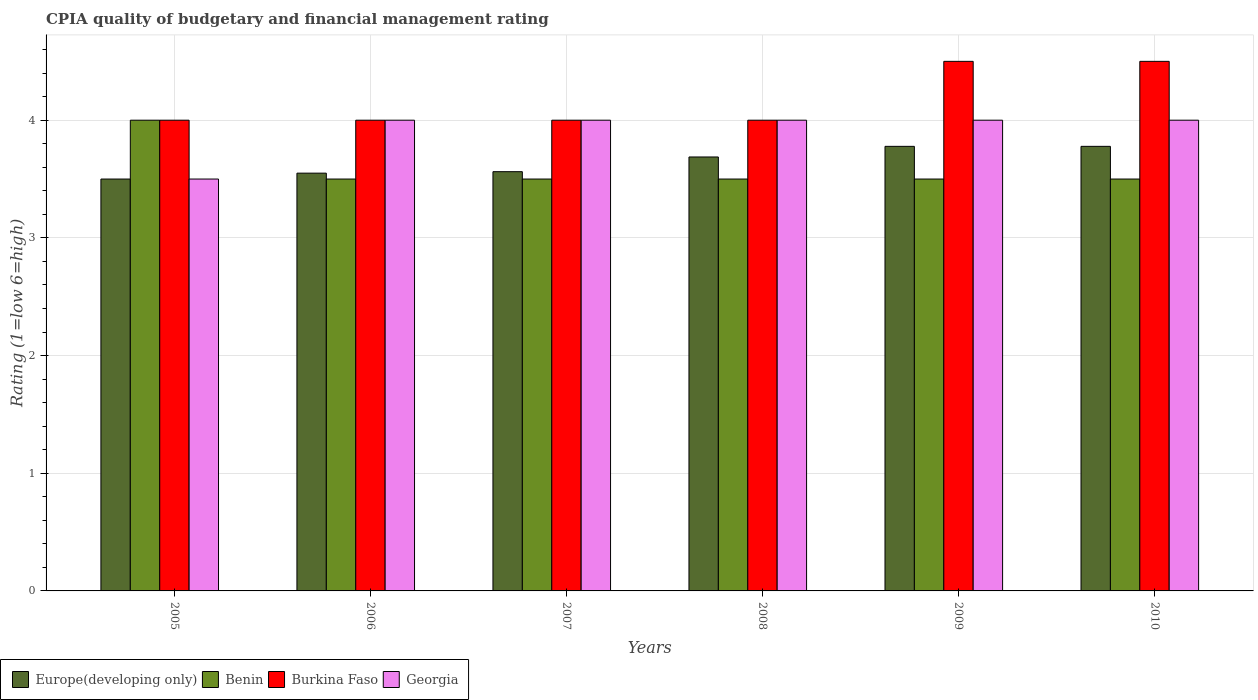How many different coloured bars are there?
Ensure brevity in your answer.  4. How many groups of bars are there?
Keep it short and to the point. 6. Are the number of bars per tick equal to the number of legend labels?
Offer a very short reply. Yes. Are the number of bars on each tick of the X-axis equal?
Offer a terse response. Yes. How many bars are there on the 3rd tick from the right?
Your answer should be very brief. 4. What is the label of the 6th group of bars from the left?
Provide a succinct answer. 2010. In how many cases, is the number of bars for a given year not equal to the number of legend labels?
Offer a very short reply. 0. What is the CPIA rating in Benin in 2005?
Keep it short and to the point. 4. Across all years, what is the maximum CPIA rating in Georgia?
Your answer should be compact. 4. Across all years, what is the minimum CPIA rating in Georgia?
Your answer should be very brief. 3.5. In which year was the CPIA rating in Georgia maximum?
Your response must be concise. 2006. In which year was the CPIA rating in Burkina Faso minimum?
Provide a short and direct response. 2005. What is the total CPIA rating in Benin in the graph?
Ensure brevity in your answer.  21.5. What is the difference between the CPIA rating in Europe(developing only) in 2005 and that in 2008?
Keep it short and to the point. -0.19. What is the difference between the CPIA rating in Benin in 2010 and the CPIA rating in Europe(developing only) in 2005?
Provide a succinct answer. 0. What is the average CPIA rating in Europe(developing only) per year?
Offer a very short reply. 3.64. In the year 2007, what is the difference between the CPIA rating in Burkina Faso and CPIA rating in Georgia?
Make the answer very short. 0. What is the ratio of the CPIA rating in Burkina Faso in 2008 to that in 2010?
Keep it short and to the point. 0.89. Is the CPIA rating in Georgia in 2007 less than that in 2009?
Your answer should be very brief. No. Is the difference between the CPIA rating in Burkina Faso in 2005 and 2009 greater than the difference between the CPIA rating in Georgia in 2005 and 2009?
Keep it short and to the point. No. In how many years, is the CPIA rating in Benin greater than the average CPIA rating in Benin taken over all years?
Offer a very short reply. 1. What does the 2nd bar from the left in 2009 represents?
Your answer should be compact. Benin. What does the 2nd bar from the right in 2008 represents?
Your answer should be compact. Burkina Faso. Is it the case that in every year, the sum of the CPIA rating in Burkina Faso and CPIA rating in Europe(developing only) is greater than the CPIA rating in Benin?
Provide a succinct answer. Yes. How many bars are there?
Provide a succinct answer. 24. Are the values on the major ticks of Y-axis written in scientific E-notation?
Provide a short and direct response. No. Does the graph contain any zero values?
Offer a very short reply. No. Does the graph contain grids?
Your answer should be very brief. Yes. What is the title of the graph?
Keep it short and to the point. CPIA quality of budgetary and financial management rating. Does "Mexico" appear as one of the legend labels in the graph?
Your response must be concise. No. What is the Rating (1=low 6=high) of Benin in 2005?
Your response must be concise. 4. What is the Rating (1=low 6=high) in Georgia in 2005?
Provide a short and direct response. 3.5. What is the Rating (1=low 6=high) in Europe(developing only) in 2006?
Your answer should be very brief. 3.55. What is the Rating (1=low 6=high) of Burkina Faso in 2006?
Provide a succinct answer. 4. What is the Rating (1=low 6=high) in Europe(developing only) in 2007?
Keep it short and to the point. 3.56. What is the Rating (1=low 6=high) of Benin in 2007?
Your answer should be very brief. 3.5. What is the Rating (1=low 6=high) in Georgia in 2007?
Ensure brevity in your answer.  4. What is the Rating (1=low 6=high) of Europe(developing only) in 2008?
Provide a short and direct response. 3.69. What is the Rating (1=low 6=high) in Benin in 2008?
Your answer should be compact. 3.5. What is the Rating (1=low 6=high) of Burkina Faso in 2008?
Offer a very short reply. 4. What is the Rating (1=low 6=high) in Georgia in 2008?
Offer a very short reply. 4. What is the Rating (1=low 6=high) in Europe(developing only) in 2009?
Ensure brevity in your answer.  3.78. What is the Rating (1=low 6=high) of Benin in 2009?
Ensure brevity in your answer.  3.5. What is the Rating (1=low 6=high) of Europe(developing only) in 2010?
Your answer should be compact. 3.78. Across all years, what is the maximum Rating (1=low 6=high) in Europe(developing only)?
Ensure brevity in your answer.  3.78. Across all years, what is the maximum Rating (1=low 6=high) in Benin?
Provide a short and direct response. 4. Across all years, what is the maximum Rating (1=low 6=high) of Burkina Faso?
Offer a terse response. 4.5. Across all years, what is the maximum Rating (1=low 6=high) in Georgia?
Offer a very short reply. 4. Across all years, what is the minimum Rating (1=low 6=high) in Burkina Faso?
Ensure brevity in your answer.  4. What is the total Rating (1=low 6=high) of Europe(developing only) in the graph?
Offer a terse response. 21.86. What is the total Rating (1=low 6=high) in Georgia in the graph?
Your response must be concise. 23.5. What is the difference between the Rating (1=low 6=high) of Europe(developing only) in 2005 and that in 2006?
Provide a succinct answer. -0.05. What is the difference between the Rating (1=low 6=high) in Benin in 2005 and that in 2006?
Offer a terse response. 0.5. What is the difference between the Rating (1=low 6=high) of Georgia in 2005 and that in 2006?
Ensure brevity in your answer.  -0.5. What is the difference between the Rating (1=low 6=high) of Europe(developing only) in 2005 and that in 2007?
Give a very brief answer. -0.06. What is the difference between the Rating (1=low 6=high) of Benin in 2005 and that in 2007?
Your answer should be very brief. 0.5. What is the difference between the Rating (1=low 6=high) of Georgia in 2005 and that in 2007?
Offer a terse response. -0.5. What is the difference between the Rating (1=low 6=high) in Europe(developing only) in 2005 and that in 2008?
Keep it short and to the point. -0.19. What is the difference between the Rating (1=low 6=high) in Benin in 2005 and that in 2008?
Keep it short and to the point. 0.5. What is the difference between the Rating (1=low 6=high) in Europe(developing only) in 2005 and that in 2009?
Keep it short and to the point. -0.28. What is the difference between the Rating (1=low 6=high) of Europe(developing only) in 2005 and that in 2010?
Your response must be concise. -0.28. What is the difference between the Rating (1=low 6=high) in Georgia in 2005 and that in 2010?
Provide a succinct answer. -0.5. What is the difference between the Rating (1=low 6=high) of Europe(developing only) in 2006 and that in 2007?
Offer a very short reply. -0.01. What is the difference between the Rating (1=low 6=high) in Burkina Faso in 2006 and that in 2007?
Your response must be concise. 0. What is the difference between the Rating (1=low 6=high) of Georgia in 2006 and that in 2007?
Offer a very short reply. 0. What is the difference between the Rating (1=low 6=high) of Europe(developing only) in 2006 and that in 2008?
Your answer should be very brief. -0.14. What is the difference between the Rating (1=low 6=high) of Georgia in 2006 and that in 2008?
Your answer should be compact. 0. What is the difference between the Rating (1=low 6=high) in Europe(developing only) in 2006 and that in 2009?
Make the answer very short. -0.23. What is the difference between the Rating (1=low 6=high) in Georgia in 2006 and that in 2009?
Give a very brief answer. 0. What is the difference between the Rating (1=low 6=high) in Europe(developing only) in 2006 and that in 2010?
Provide a succinct answer. -0.23. What is the difference between the Rating (1=low 6=high) in Europe(developing only) in 2007 and that in 2008?
Make the answer very short. -0.12. What is the difference between the Rating (1=low 6=high) in Burkina Faso in 2007 and that in 2008?
Give a very brief answer. 0. What is the difference between the Rating (1=low 6=high) in Europe(developing only) in 2007 and that in 2009?
Provide a short and direct response. -0.22. What is the difference between the Rating (1=low 6=high) in Benin in 2007 and that in 2009?
Give a very brief answer. 0. What is the difference between the Rating (1=low 6=high) of Burkina Faso in 2007 and that in 2009?
Ensure brevity in your answer.  -0.5. What is the difference between the Rating (1=low 6=high) in Georgia in 2007 and that in 2009?
Keep it short and to the point. 0. What is the difference between the Rating (1=low 6=high) of Europe(developing only) in 2007 and that in 2010?
Keep it short and to the point. -0.22. What is the difference between the Rating (1=low 6=high) in Burkina Faso in 2007 and that in 2010?
Your answer should be compact. -0.5. What is the difference between the Rating (1=low 6=high) of Georgia in 2007 and that in 2010?
Make the answer very short. 0. What is the difference between the Rating (1=low 6=high) of Europe(developing only) in 2008 and that in 2009?
Provide a short and direct response. -0.09. What is the difference between the Rating (1=low 6=high) in Burkina Faso in 2008 and that in 2009?
Your response must be concise. -0.5. What is the difference between the Rating (1=low 6=high) in Europe(developing only) in 2008 and that in 2010?
Give a very brief answer. -0.09. What is the difference between the Rating (1=low 6=high) of Burkina Faso in 2008 and that in 2010?
Offer a very short reply. -0.5. What is the difference between the Rating (1=low 6=high) of Georgia in 2008 and that in 2010?
Make the answer very short. 0. What is the difference between the Rating (1=low 6=high) of Benin in 2009 and that in 2010?
Give a very brief answer. 0. What is the difference between the Rating (1=low 6=high) in Burkina Faso in 2009 and that in 2010?
Make the answer very short. 0. What is the difference between the Rating (1=low 6=high) of Georgia in 2009 and that in 2010?
Your answer should be very brief. 0. What is the difference between the Rating (1=low 6=high) of Europe(developing only) in 2005 and the Rating (1=low 6=high) of Benin in 2006?
Your answer should be very brief. 0. What is the difference between the Rating (1=low 6=high) of Benin in 2005 and the Rating (1=low 6=high) of Burkina Faso in 2006?
Provide a succinct answer. 0. What is the difference between the Rating (1=low 6=high) of Burkina Faso in 2005 and the Rating (1=low 6=high) of Georgia in 2006?
Provide a succinct answer. 0. What is the difference between the Rating (1=low 6=high) in Europe(developing only) in 2005 and the Rating (1=low 6=high) in Benin in 2007?
Ensure brevity in your answer.  0. What is the difference between the Rating (1=low 6=high) of Europe(developing only) in 2005 and the Rating (1=low 6=high) of Burkina Faso in 2007?
Make the answer very short. -0.5. What is the difference between the Rating (1=low 6=high) of Europe(developing only) in 2005 and the Rating (1=low 6=high) of Georgia in 2007?
Give a very brief answer. -0.5. What is the difference between the Rating (1=low 6=high) of Benin in 2005 and the Rating (1=low 6=high) of Georgia in 2007?
Your answer should be very brief. 0. What is the difference between the Rating (1=low 6=high) of Burkina Faso in 2005 and the Rating (1=low 6=high) of Georgia in 2007?
Your response must be concise. 0. What is the difference between the Rating (1=low 6=high) in Europe(developing only) in 2005 and the Rating (1=low 6=high) in Georgia in 2008?
Your response must be concise. -0.5. What is the difference between the Rating (1=low 6=high) of Europe(developing only) in 2005 and the Rating (1=low 6=high) of Benin in 2009?
Ensure brevity in your answer.  0. What is the difference between the Rating (1=low 6=high) of Europe(developing only) in 2005 and the Rating (1=low 6=high) of Burkina Faso in 2009?
Provide a succinct answer. -1. What is the difference between the Rating (1=low 6=high) in Europe(developing only) in 2005 and the Rating (1=low 6=high) in Georgia in 2009?
Ensure brevity in your answer.  -0.5. What is the difference between the Rating (1=low 6=high) of Benin in 2005 and the Rating (1=low 6=high) of Georgia in 2009?
Offer a very short reply. 0. What is the difference between the Rating (1=low 6=high) in Burkina Faso in 2005 and the Rating (1=low 6=high) in Georgia in 2009?
Provide a short and direct response. 0. What is the difference between the Rating (1=low 6=high) of Europe(developing only) in 2005 and the Rating (1=low 6=high) of Burkina Faso in 2010?
Make the answer very short. -1. What is the difference between the Rating (1=low 6=high) in Europe(developing only) in 2005 and the Rating (1=low 6=high) in Georgia in 2010?
Give a very brief answer. -0.5. What is the difference between the Rating (1=low 6=high) in Benin in 2005 and the Rating (1=low 6=high) in Georgia in 2010?
Your answer should be compact. 0. What is the difference between the Rating (1=low 6=high) of Burkina Faso in 2005 and the Rating (1=low 6=high) of Georgia in 2010?
Provide a short and direct response. 0. What is the difference between the Rating (1=low 6=high) in Europe(developing only) in 2006 and the Rating (1=low 6=high) in Benin in 2007?
Provide a succinct answer. 0.05. What is the difference between the Rating (1=low 6=high) in Europe(developing only) in 2006 and the Rating (1=low 6=high) in Burkina Faso in 2007?
Offer a terse response. -0.45. What is the difference between the Rating (1=low 6=high) in Europe(developing only) in 2006 and the Rating (1=low 6=high) in Georgia in 2007?
Your answer should be very brief. -0.45. What is the difference between the Rating (1=low 6=high) in Benin in 2006 and the Rating (1=low 6=high) in Burkina Faso in 2007?
Offer a very short reply. -0.5. What is the difference between the Rating (1=low 6=high) of Benin in 2006 and the Rating (1=low 6=high) of Georgia in 2007?
Your answer should be compact. -0.5. What is the difference between the Rating (1=low 6=high) of Europe(developing only) in 2006 and the Rating (1=low 6=high) of Benin in 2008?
Your answer should be compact. 0.05. What is the difference between the Rating (1=low 6=high) of Europe(developing only) in 2006 and the Rating (1=low 6=high) of Burkina Faso in 2008?
Your answer should be compact. -0.45. What is the difference between the Rating (1=low 6=high) in Europe(developing only) in 2006 and the Rating (1=low 6=high) in Georgia in 2008?
Offer a very short reply. -0.45. What is the difference between the Rating (1=low 6=high) of Europe(developing only) in 2006 and the Rating (1=low 6=high) of Burkina Faso in 2009?
Offer a very short reply. -0.95. What is the difference between the Rating (1=low 6=high) of Europe(developing only) in 2006 and the Rating (1=low 6=high) of Georgia in 2009?
Offer a very short reply. -0.45. What is the difference between the Rating (1=low 6=high) of Benin in 2006 and the Rating (1=low 6=high) of Burkina Faso in 2009?
Keep it short and to the point. -1. What is the difference between the Rating (1=low 6=high) of Benin in 2006 and the Rating (1=low 6=high) of Georgia in 2009?
Ensure brevity in your answer.  -0.5. What is the difference between the Rating (1=low 6=high) of Europe(developing only) in 2006 and the Rating (1=low 6=high) of Benin in 2010?
Your answer should be compact. 0.05. What is the difference between the Rating (1=low 6=high) in Europe(developing only) in 2006 and the Rating (1=low 6=high) in Burkina Faso in 2010?
Provide a short and direct response. -0.95. What is the difference between the Rating (1=low 6=high) of Europe(developing only) in 2006 and the Rating (1=low 6=high) of Georgia in 2010?
Keep it short and to the point. -0.45. What is the difference between the Rating (1=low 6=high) of Benin in 2006 and the Rating (1=low 6=high) of Burkina Faso in 2010?
Offer a terse response. -1. What is the difference between the Rating (1=low 6=high) of Benin in 2006 and the Rating (1=low 6=high) of Georgia in 2010?
Ensure brevity in your answer.  -0.5. What is the difference between the Rating (1=low 6=high) of Europe(developing only) in 2007 and the Rating (1=low 6=high) of Benin in 2008?
Offer a terse response. 0.06. What is the difference between the Rating (1=low 6=high) in Europe(developing only) in 2007 and the Rating (1=low 6=high) in Burkina Faso in 2008?
Your response must be concise. -0.44. What is the difference between the Rating (1=low 6=high) of Europe(developing only) in 2007 and the Rating (1=low 6=high) of Georgia in 2008?
Keep it short and to the point. -0.44. What is the difference between the Rating (1=low 6=high) in Benin in 2007 and the Rating (1=low 6=high) in Georgia in 2008?
Keep it short and to the point. -0.5. What is the difference between the Rating (1=low 6=high) of Burkina Faso in 2007 and the Rating (1=low 6=high) of Georgia in 2008?
Offer a terse response. 0. What is the difference between the Rating (1=low 6=high) of Europe(developing only) in 2007 and the Rating (1=low 6=high) of Benin in 2009?
Give a very brief answer. 0.06. What is the difference between the Rating (1=low 6=high) in Europe(developing only) in 2007 and the Rating (1=low 6=high) in Burkina Faso in 2009?
Your answer should be very brief. -0.94. What is the difference between the Rating (1=low 6=high) of Europe(developing only) in 2007 and the Rating (1=low 6=high) of Georgia in 2009?
Your answer should be very brief. -0.44. What is the difference between the Rating (1=low 6=high) of Benin in 2007 and the Rating (1=low 6=high) of Burkina Faso in 2009?
Your answer should be compact. -1. What is the difference between the Rating (1=low 6=high) in Europe(developing only) in 2007 and the Rating (1=low 6=high) in Benin in 2010?
Make the answer very short. 0.06. What is the difference between the Rating (1=low 6=high) in Europe(developing only) in 2007 and the Rating (1=low 6=high) in Burkina Faso in 2010?
Ensure brevity in your answer.  -0.94. What is the difference between the Rating (1=low 6=high) in Europe(developing only) in 2007 and the Rating (1=low 6=high) in Georgia in 2010?
Offer a terse response. -0.44. What is the difference between the Rating (1=low 6=high) of Benin in 2007 and the Rating (1=low 6=high) of Burkina Faso in 2010?
Your answer should be very brief. -1. What is the difference between the Rating (1=low 6=high) of Europe(developing only) in 2008 and the Rating (1=low 6=high) of Benin in 2009?
Ensure brevity in your answer.  0.19. What is the difference between the Rating (1=low 6=high) in Europe(developing only) in 2008 and the Rating (1=low 6=high) in Burkina Faso in 2009?
Give a very brief answer. -0.81. What is the difference between the Rating (1=low 6=high) in Europe(developing only) in 2008 and the Rating (1=low 6=high) in Georgia in 2009?
Your response must be concise. -0.31. What is the difference between the Rating (1=low 6=high) in Benin in 2008 and the Rating (1=low 6=high) in Burkina Faso in 2009?
Keep it short and to the point. -1. What is the difference between the Rating (1=low 6=high) of Burkina Faso in 2008 and the Rating (1=low 6=high) of Georgia in 2009?
Offer a terse response. 0. What is the difference between the Rating (1=low 6=high) in Europe(developing only) in 2008 and the Rating (1=low 6=high) in Benin in 2010?
Your response must be concise. 0.19. What is the difference between the Rating (1=low 6=high) of Europe(developing only) in 2008 and the Rating (1=low 6=high) of Burkina Faso in 2010?
Ensure brevity in your answer.  -0.81. What is the difference between the Rating (1=low 6=high) of Europe(developing only) in 2008 and the Rating (1=low 6=high) of Georgia in 2010?
Your response must be concise. -0.31. What is the difference between the Rating (1=low 6=high) in Europe(developing only) in 2009 and the Rating (1=low 6=high) in Benin in 2010?
Provide a succinct answer. 0.28. What is the difference between the Rating (1=low 6=high) in Europe(developing only) in 2009 and the Rating (1=low 6=high) in Burkina Faso in 2010?
Offer a very short reply. -0.72. What is the difference between the Rating (1=low 6=high) in Europe(developing only) in 2009 and the Rating (1=low 6=high) in Georgia in 2010?
Offer a terse response. -0.22. What is the difference between the Rating (1=low 6=high) in Burkina Faso in 2009 and the Rating (1=low 6=high) in Georgia in 2010?
Your answer should be very brief. 0.5. What is the average Rating (1=low 6=high) of Europe(developing only) per year?
Give a very brief answer. 3.64. What is the average Rating (1=low 6=high) in Benin per year?
Give a very brief answer. 3.58. What is the average Rating (1=low 6=high) in Burkina Faso per year?
Provide a short and direct response. 4.17. What is the average Rating (1=low 6=high) of Georgia per year?
Provide a succinct answer. 3.92. In the year 2005, what is the difference between the Rating (1=low 6=high) of Europe(developing only) and Rating (1=low 6=high) of Benin?
Your answer should be compact. -0.5. In the year 2005, what is the difference between the Rating (1=low 6=high) in Benin and Rating (1=low 6=high) in Georgia?
Offer a very short reply. 0.5. In the year 2005, what is the difference between the Rating (1=low 6=high) of Burkina Faso and Rating (1=low 6=high) of Georgia?
Make the answer very short. 0.5. In the year 2006, what is the difference between the Rating (1=low 6=high) in Europe(developing only) and Rating (1=low 6=high) in Benin?
Provide a succinct answer. 0.05. In the year 2006, what is the difference between the Rating (1=low 6=high) of Europe(developing only) and Rating (1=low 6=high) of Burkina Faso?
Offer a very short reply. -0.45. In the year 2006, what is the difference between the Rating (1=low 6=high) of Europe(developing only) and Rating (1=low 6=high) of Georgia?
Give a very brief answer. -0.45. In the year 2006, what is the difference between the Rating (1=low 6=high) of Benin and Rating (1=low 6=high) of Burkina Faso?
Give a very brief answer. -0.5. In the year 2007, what is the difference between the Rating (1=low 6=high) in Europe(developing only) and Rating (1=low 6=high) in Benin?
Provide a succinct answer. 0.06. In the year 2007, what is the difference between the Rating (1=low 6=high) in Europe(developing only) and Rating (1=low 6=high) in Burkina Faso?
Give a very brief answer. -0.44. In the year 2007, what is the difference between the Rating (1=low 6=high) of Europe(developing only) and Rating (1=low 6=high) of Georgia?
Offer a terse response. -0.44. In the year 2007, what is the difference between the Rating (1=low 6=high) of Benin and Rating (1=low 6=high) of Burkina Faso?
Keep it short and to the point. -0.5. In the year 2007, what is the difference between the Rating (1=low 6=high) in Burkina Faso and Rating (1=low 6=high) in Georgia?
Make the answer very short. 0. In the year 2008, what is the difference between the Rating (1=low 6=high) in Europe(developing only) and Rating (1=low 6=high) in Benin?
Keep it short and to the point. 0.19. In the year 2008, what is the difference between the Rating (1=low 6=high) in Europe(developing only) and Rating (1=low 6=high) in Burkina Faso?
Give a very brief answer. -0.31. In the year 2008, what is the difference between the Rating (1=low 6=high) in Europe(developing only) and Rating (1=low 6=high) in Georgia?
Give a very brief answer. -0.31. In the year 2008, what is the difference between the Rating (1=low 6=high) of Benin and Rating (1=low 6=high) of Georgia?
Ensure brevity in your answer.  -0.5. In the year 2008, what is the difference between the Rating (1=low 6=high) in Burkina Faso and Rating (1=low 6=high) in Georgia?
Your answer should be very brief. 0. In the year 2009, what is the difference between the Rating (1=low 6=high) in Europe(developing only) and Rating (1=low 6=high) in Benin?
Offer a terse response. 0.28. In the year 2009, what is the difference between the Rating (1=low 6=high) of Europe(developing only) and Rating (1=low 6=high) of Burkina Faso?
Your answer should be very brief. -0.72. In the year 2009, what is the difference between the Rating (1=low 6=high) in Europe(developing only) and Rating (1=low 6=high) in Georgia?
Provide a succinct answer. -0.22. In the year 2009, what is the difference between the Rating (1=low 6=high) of Benin and Rating (1=low 6=high) of Burkina Faso?
Offer a very short reply. -1. In the year 2010, what is the difference between the Rating (1=low 6=high) of Europe(developing only) and Rating (1=low 6=high) of Benin?
Keep it short and to the point. 0.28. In the year 2010, what is the difference between the Rating (1=low 6=high) in Europe(developing only) and Rating (1=low 6=high) in Burkina Faso?
Your answer should be compact. -0.72. In the year 2010, what is the difference between the Rating (1=low 6=high) in Europe(developing only) and Rating (1=low 6=high) in Georgia?
Make the answer very short. -0.22. In the year 2010, what is the difference between the Rating (1=low 6=high) of Benin and Rating (1=low 6=high) of Burkina Faso?
Your answer should be compact. -1. In the year 2010, what is the difference between the Rating (1=low 6=high) in Benin and Rating (1=low 6=high) in Georgia?
Ensure brevity in your answer.  -0.5. In the year 2010, what is the difference between the Rating (1=low 6=high) of Burkina Faso and Rating (1=low 6=high) of Georgia?
Provide a succinct answer. 0.5. What is the ratio of the Rating (1=low 6=high) in Europe(developing only) in 2005 to that in 2006?
Make the answer very short. 0.99. What is the ratio of the Rating (1=low 6=high) in Burkina Faso in 2005 to that in 2006?
Ensure brevity in your answer.  1. What is the ratio of the Rating (1=low 6=high) in Europe(developing only) in 2005 to that in 2007?
Offer a very short reply. 0.98. What is the ratio of the Rating (1=low 6=high) of Benin in 2005 to that in 2007?
Keep it short and to the point. 1.14. What is the ratio of the Rating (1=low 6=high) in Georgia in 2005 to that in 2007?
Provide a short and direct response. 0.88. What is the ratio of the Rating (1=low 6=high) of Europe(developing only) in 2005 to that in 2008?
Provide a short and direct response. 0.95. What is the ratio of the Rating (1=low 6=high) of Benin in 2005 to that in 2008?
Your answer should be compact. 1.14. What is the ratio of the Rating (1=low 6=high) of Burkina Faso in 2005 to that in 2008?
Make the answer very short. 1. What is the ratio of the Rating (1=low 6=high) in Europe(developing only) in 2005 to that in 2009?
Your answer should be compact. 0.93. What is the ratio of the Rating (1=low 6=high) of Benin in 2005 to that in 2009?
Keep it short and to the point. 1.14. What is the ratio of the Rating (1=low 6=high) in Burkina Faso in 2005 to that in 2009?
Keep it short and to the point. 0.89. What is the ratio of the Rating (1=low 6=high) in Europe(developing only) in 2005 to that in 2010?
Make the answer very short. 0.93. What is the ratio of the Rating (1=low 6=high) of Benin in 2005 to that in 2010?
Your response must be concise. 1.14. What is the ratio of the Rating (1=low 6=high) of Benin in 2006 to that in 2007?
Make the answer very short. 1. What is the ratio of the Rating (1=low 6=high) in Europe(developing only) in 2006 to that in 2008?
Your response must be concise. 0.96. What is the ratio of the Rating (1=low 6=high) of Burkina Faso in 2006 to that in 2008?
Provide a succinct answer. 1. What is the ratio of the Rating (1=low 6=high) in Europe(developing only) in 2006 to that in 2009?
Give a very brief answer. 0.94. What is the ratio of the Rating (1=low 6=high) in Burkina Faso in 2006 to that in 2009?
Offer a very short reply. 0.89. What is the ratio of the Rating (1=low 6=high) in Europe(developing only) in 2006 to that in 2010?
Your answer should be compact. 0.94. What is the ratio of the Rating (1=low 6=high) in Burkina Faso in 2006 to that in 2010?
Your answer should be compact. 0.89. What is the ratio of the Rating (1=low 6=high) in Europe(developing only) in 2007 to that in 2008?
Ensure brevity in your answer.  0.97. What is the ratio of the Rating (1=low 6=high) of Benin in 2007 to that in 2008?
Provide a succinct answer. 1. What is the ratio of the Rating (1=low 6=high) of Europe(developing only) in 2007 to that in 2009?
Your response must be concise. 0.94. What is the ratio of the Rating (1=low 6=high) of Benin in 2007 to that in 2009?
Give a very brief answer. 1. What is the ratio of the Rating (1=low 6=high) of Burkina Faso in 2007 to that in 2009?
Provide a short and direct response. 0.89. What is the ratio of the Rating (1=low 6=high) of Georgia in 2007 to that in 2009?
Keep it short and to the point. 1. What is the ratio of the Rating (1=low 6=high) of Europe(developing only) in 2007 to that in 2010?
Keep it short and to the point. 0.94. What is the ratio of the Rating (1=low 6=high) of Benin in 2007 to that in 2010?
Offer a terse response. 1. What is the ratio of the Rating (1=low 6=high) in Georgia in 2007 to that in 2010?
Your response must be concise. 1. What is the ratio of the Rating (1=low 6=high) of Europe(developing only) in 2008 to that in 2009?
Ensure brevity in your answer.  0.98. What is the ratio of the Rating (1=low 6=high) of Europe(developing only) in 2008 to that in 2010?
Ensure brevity in your answer.  0.98. What is the ratio of the Rating (1=low 6=high) in Benin in 2008 to that in 2010?
Make the answer very short. 1. What is the ratio of the Rating (1=low 6=high) in Europe(developing only) in 2009 to that in 2010?
Provide a short and direct response. 1. What is the ratio of the Rating (1=low 6=high) of Burkina Faso in 2009 to that in 2010?
Offer a very short reply. 1. What is the difference between the highest and the second highest Rating (1=low 6=high) in Europe(developing only)?
Keep it short and to the point. 0. What is the difference between the highest and the second highest Rating (1=low 6=high) in Burkina Faso?
Your response must be concise. 0. What is the difference between the highest and the second highest Rating (1=low 6=high) of Georgia?
Offer a terse response. 0. What is the difference between the highest and the lowest Rating (1=low 6=high) of Europe(developing only)?
Make the answer very short. 0.28. What is the difference between the highest and the lowest Rating (1=low 6=high) of Georgia?
Offer a terse response. 0.5. 